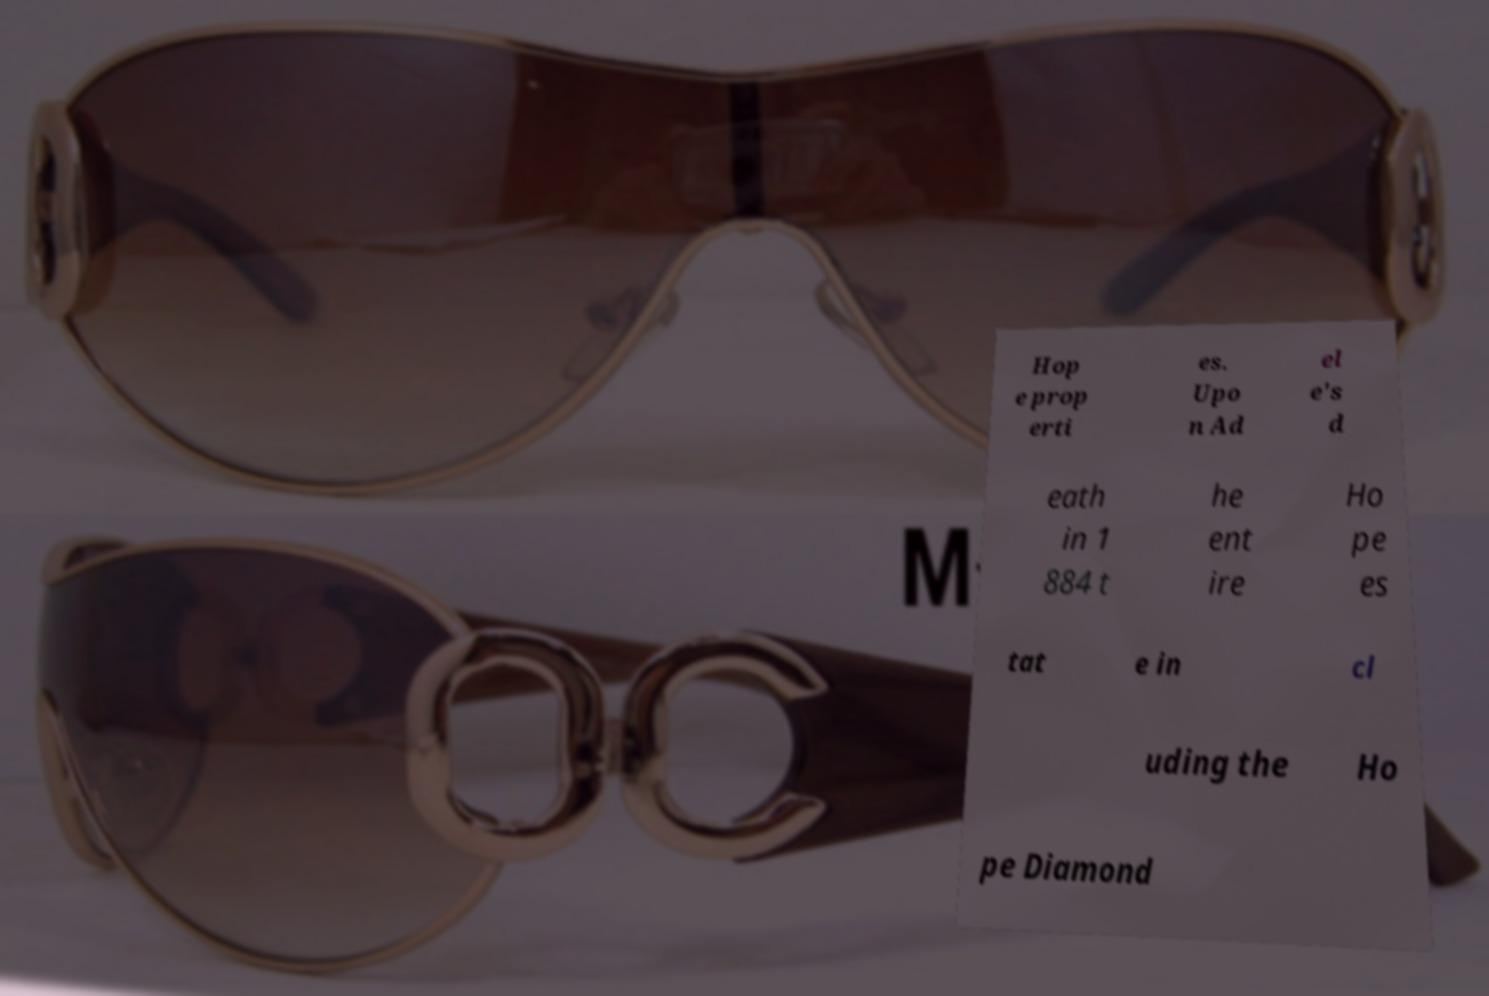Please identify and transcribe the text found in this image. Hop e prop erti es. Upo n Ad el e's d eath in 1 884 t he ent ire Ho pe es tat e in cl uding the Ho pe Diamond 